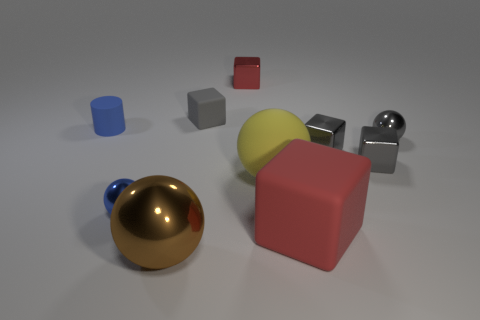What time of day does the lighting in this scene suggest? The brightness and the neutral color of the lighting suggest an indoor setting with artificial lighting, rather than natural daylight, which doesn't indicate a specific time of day. 